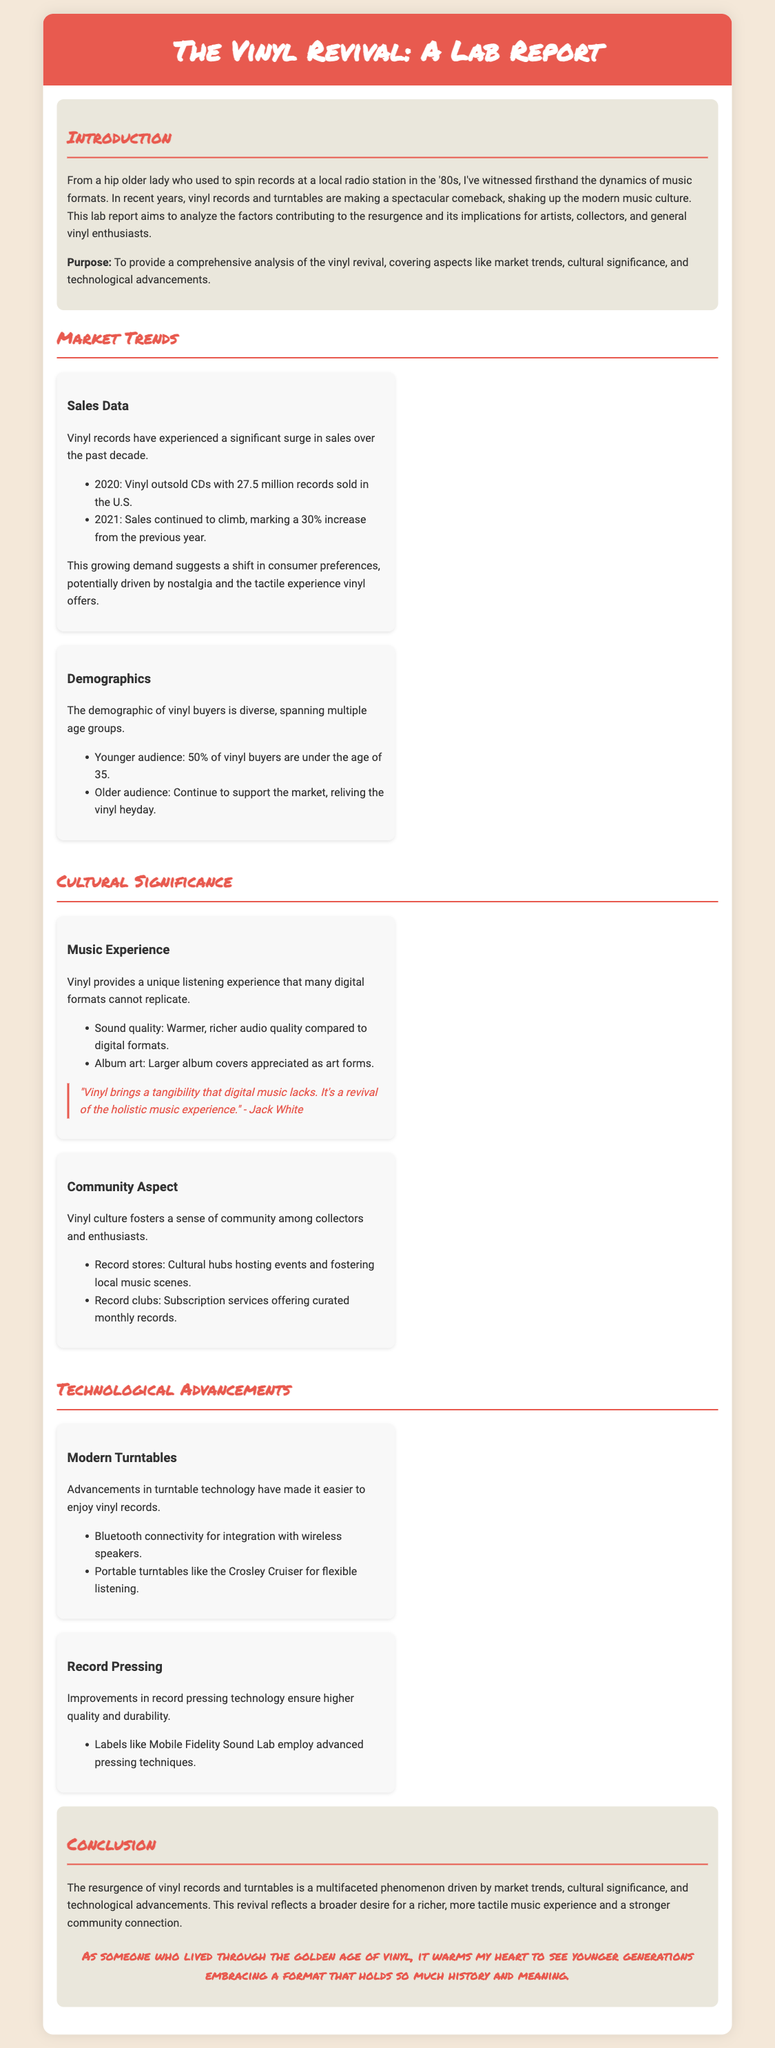what year did vinyl outsell CDs? The document states that vinyl outsold CDs in the year 2020, marking a significant moment in the vinyl revival.
Answer: 2020 what was the sales increase percentage in 2021? The report indicates that vinyl sales climbed by 30% from the previous year, highlighting the growing popularity of vinyl records.
Answer: 30% what percentage of vinyl buyers are under the age of 35? The document reports that 50% of vinyl buyers fall under this age group, showcasing the youthful demographic involved in the vinyl revival.
Answer: 50% what is a unique feature of the music experience provided by vinyl? According to the report, vinyl offers warmer, richer audio quality compared to digital formats, which enhances the listening experience.
Answer: Warmer, richer audio quality who made a notable quote about vinyl? The report cites Jack White as someone who emphasized the tangible experience of vinyl compared to digital music.
Answer: Jack White what is one technological advancement mentioned for modern turntables? The document highlights Bluetooth connectivity as a key feature in modern turntables, facilitating integration with wireless speakers.
Answer: Bluetooth connectivity what has improved in record pressing technology? The document mentions that advanced pressing techniques are employed by labels like Mobile Fidelity Sound Lab, which ensures higher quality records.
Answer: Higher quality what is the purpose of this lab report? The report states that its purpose is to provide a comprehensive analysis of the vinyl revival, including market trends and cultural significance.
Answer: Comprehensive analysis of the vinyl revival what is the conclusion drawn about the vinyl revival? The conclusion emphasizes that the resurgence reflects a desire for a richer, tactile music experience and a stronger community connection.
Answer: Richer, tactile music experience 